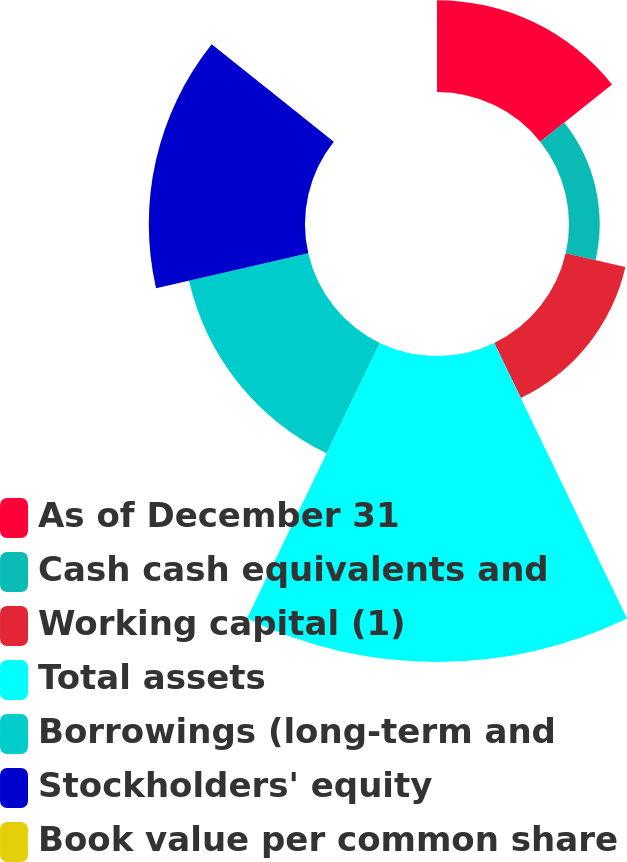<chart> <loc_0><loc_0><loc_500><loc_500><pie_chart><fcel>As of December 31<fcel>Cash cash equivalents and<fcel>Working capital (1)<fcel>Total assets<fcel>Borrowings (long-term and<fcel>Stockholders' equity<fcel>Book value per common share<nl><fcel>11.95%<fcel>3.99%<fcel>7.97%<fcel>39.81%<fcel>15.93%<fcel>20.32%<fcel>0.01%<nl></chart> 